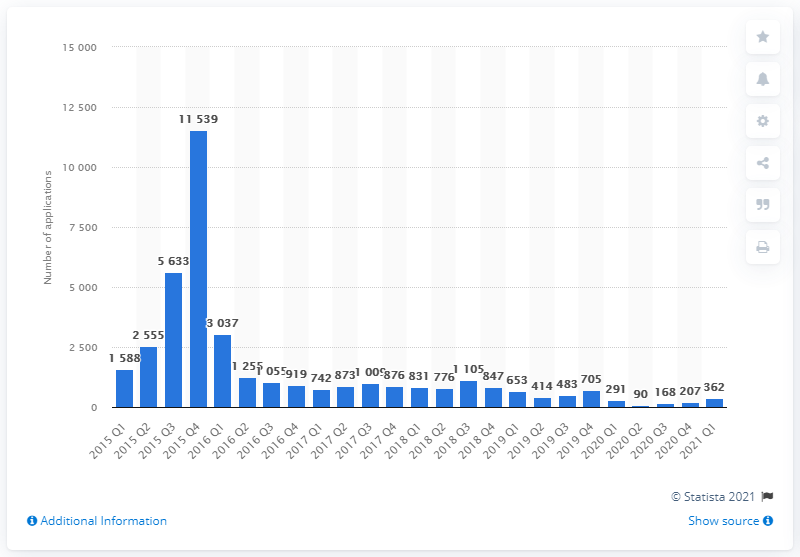List a handful of essential elements in this visual. In the first quarter of 2010, a total of 362 asylum applications were submitted in Denmark. 